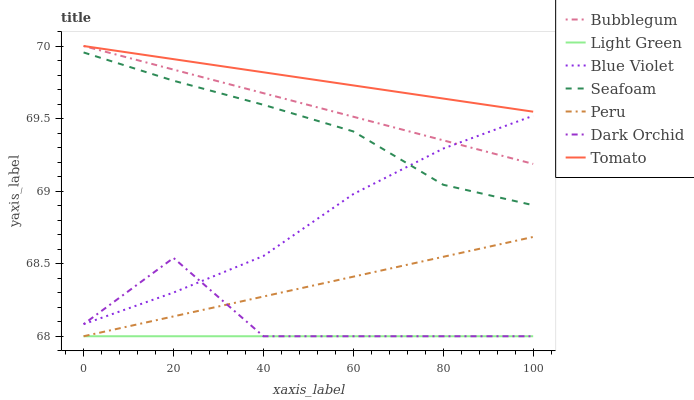Does Seafoam have the minimum area under the curve?
Answer yes or no. No. Does Seafoam have the maximum area under the curve?
Answer yes or no. No. Is Seafoam the smoothest?
Answer yes or no. No. Is Seafoam the roughest?
Answer yes or no. No. Does Seafoam have the lowest value?
Answer yes or no. No. Does Seafoam have the highest value?
Answer yes or no. No. Is Blue Violet less than Tomato?
Answer yes or no. Yes. Is Blue Violet greater than Peru?
Answer yes or no. Yes. Does Blue Violet intersect Tomato?
Answer yes or no. No. 